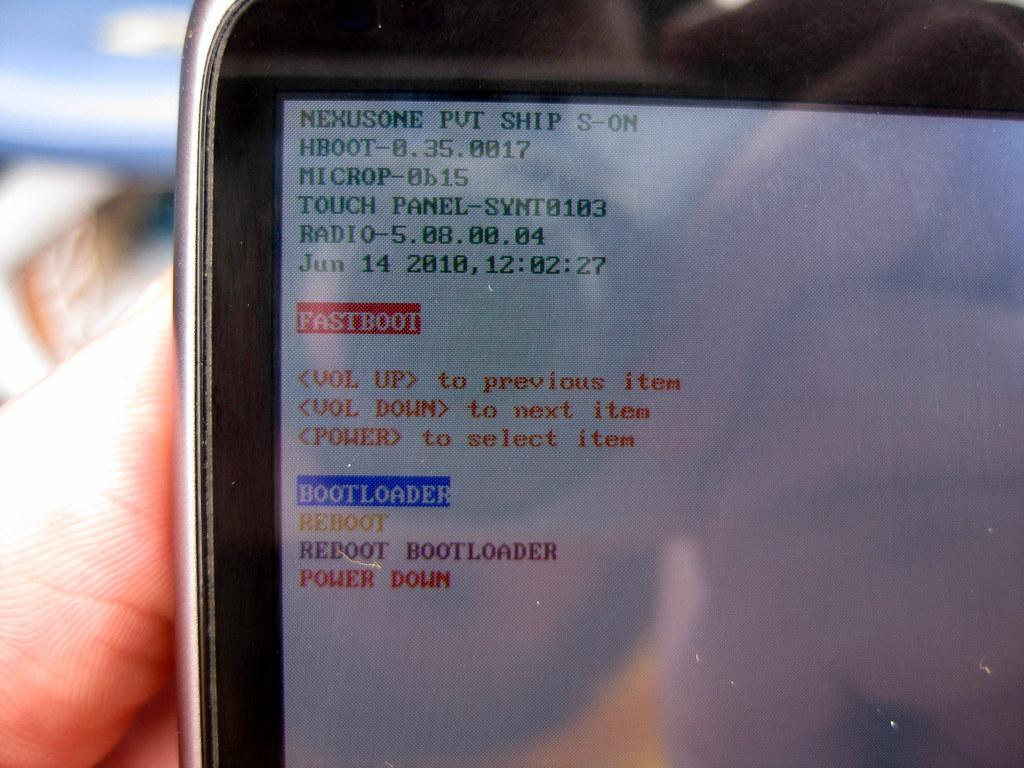<image>
Share a concise interpretation of the image provided. a digital device has the word FASTBOOT as well as other writing on it 